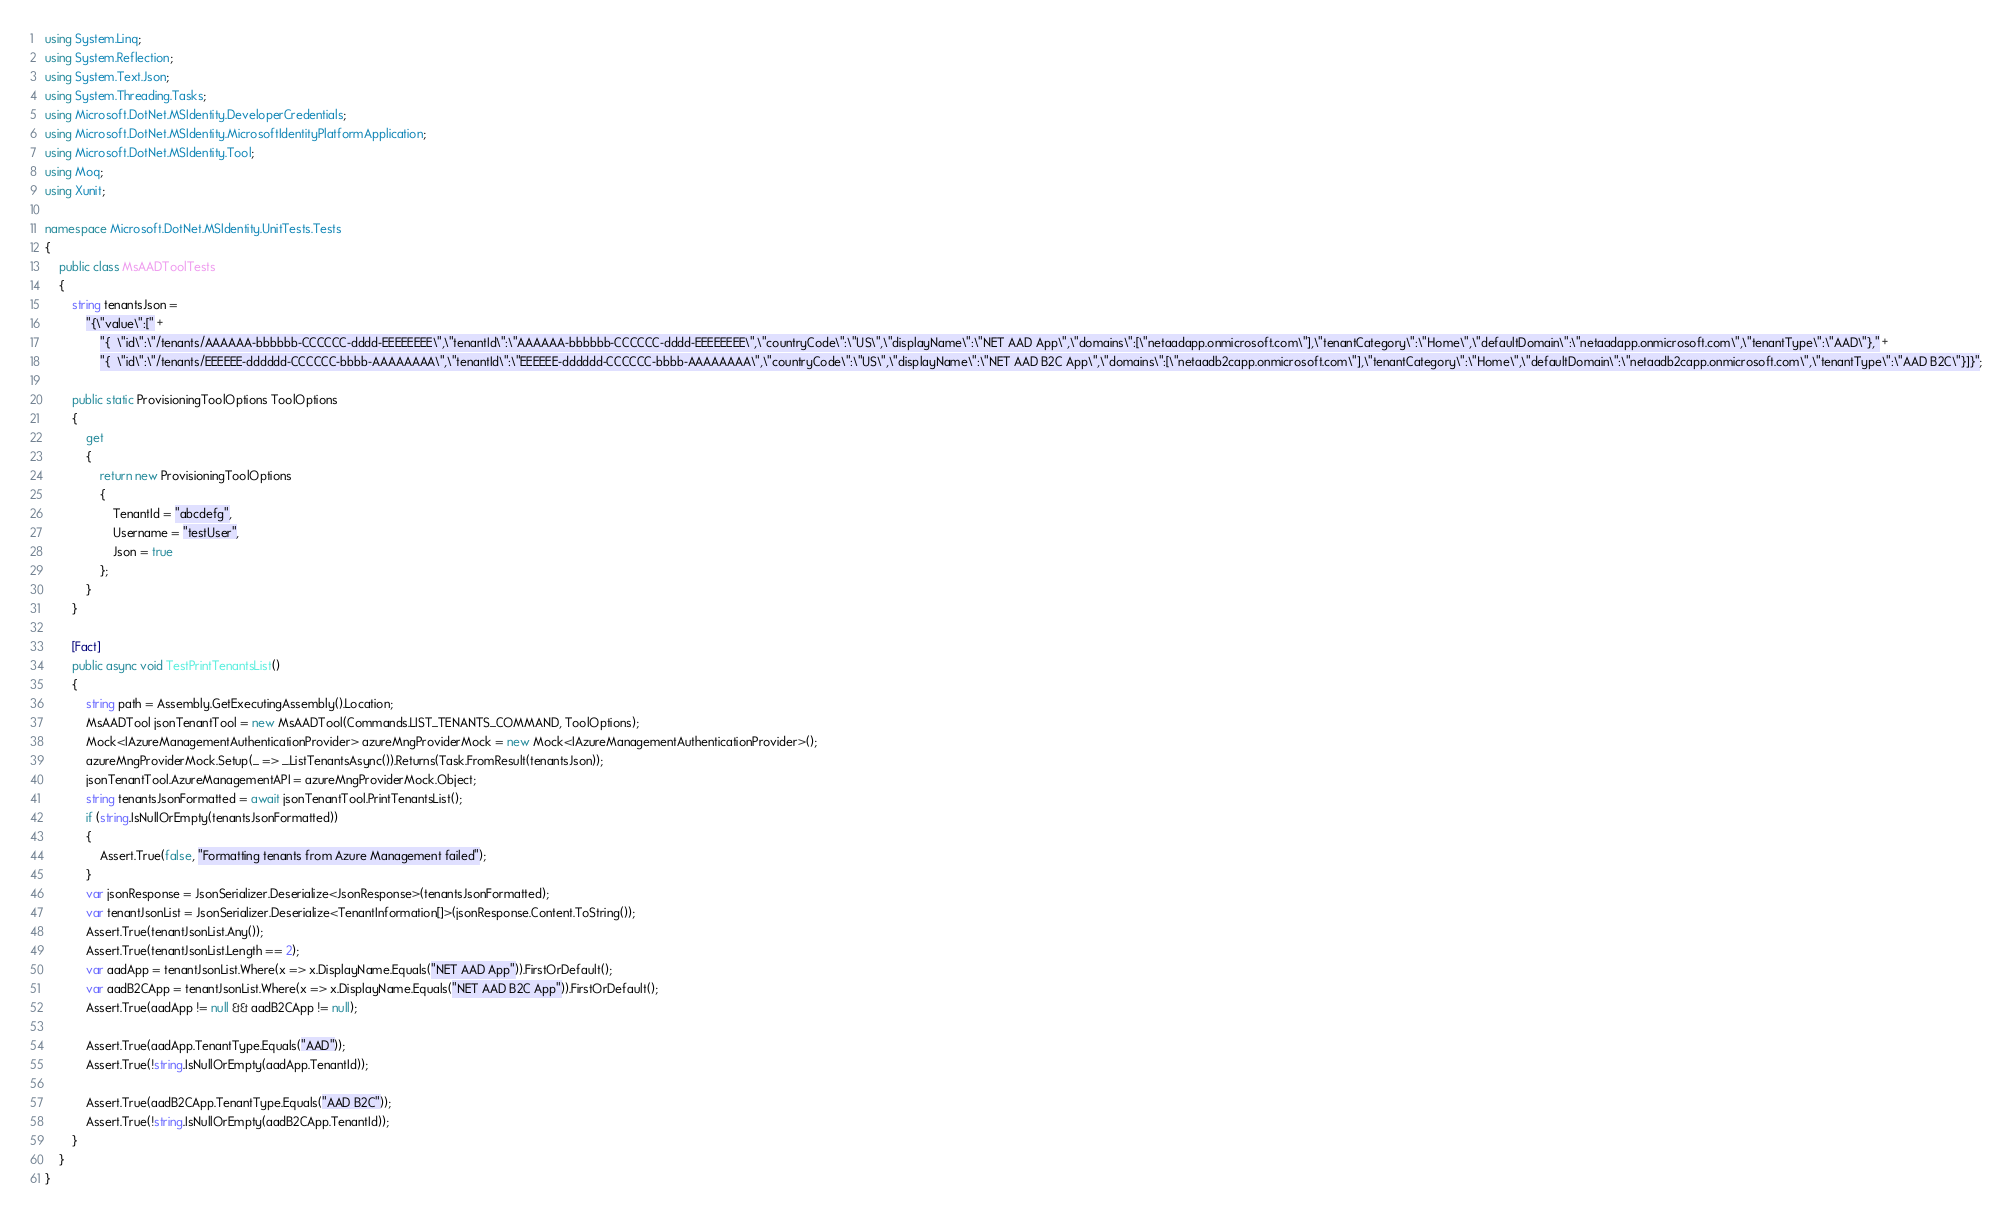Convert code to text. <code><loc_0><loc_0><loc_500><loc_500><_C#_>using System.Linq;
using System.Reflection;
using System.Text.Json;
using System.Threading.Tasks;
using Microsoft.DotNet.MSIdentity.DeveloperCredentials;
using Microsoft.DotNet.MSIdentity.MicrosoftIdentityPlatformApplication;
using Microsoft.DotNet.MSIdentity.Tool;
using Moq;
using Xunit;

namespace Microsoft.DotNet.MSIdentity.UnitTests.Tests
{
    public class MsAADToolTests
    {
        string tenantsJson =
            "{\"value\":[" +
                "{  \"id\":\"/tenants/AAAAAA-bbbbbb-CCCCCC-dddd-EEEEEEEE\",\"tenantId\":\"AAAAAA-bbbbbb-CCCCCC-dddd-EEEEEEEE\",\"countryCode\":\"US\",\"displayName\":\"NET AAD App\",\"domains\":[\"netaadapp.onmicrosoft.com\"],\"tenantCategory\":\"Home\",\"defaultDomain\":\"netaadapp.onmicrosoft.com\",\"tenantType\":\"AAD\"}," +
                "{  \"id\":\"/tenants/EEEEEE-dddddd-CCCCCC-bbbb-AAAAAAAA\",\"tenantId\":\"EEEEEE-dddddd-CCCCCC-bbbb-AAAAAAAA\",\"countryCode\":\"US\",\"displayName\":\"NET AAD B2C App\",\"domains\":[\"netaadb2capp.onmicrosoft.com\"],\"tenantCategory\":\"Home\",\"defaultDomain\":\"netaadb2capp.onmicrosoft.com\",\"tenantType\":\"AAD B2C\"}]}";

        public static ProvisioningToolOptions ToolOptions 
        {
            get 
            {
                return new ProvisioningToolOptions 
                {
                    TenantId = "abcdefg",
                    Username = "testUser",
                    Json = true
                };
            }
        }

        [Fact]
        public async void TestPrintTenantsList()
        {
            string path = Assembly.GetExecutingAssembly().Location;
            MsAADTool jsonTenantTool = new MsAADTool(Commands.LIST_TENANTS_COMMAND, ToolOptions);
            Mock<IAzureManagementAuthenticationProvider> azureMngProviderMock = new Mock<IAzureManagementAuthenticationProvider>();
            azureMngProviderMock.Setup(_ => _.ListTenantsAsync()).Returns(Task.FromResult(tenantsJson));
            jsonTenantTool.AzureManagementAPI = azureMngProviderMock.Object;
            string tenantsJsonFormatted = await jsonTenantTool.PrintTenantsList();
            if (string.IsNullOrEmpty(tenantsJsonFormatted))
            {
                Assert.True(false, "Formatting tenants from Azure Management failed");
            }
            var jsonResponse = JsonSerializer.Deserialize<JsonResponse>(tenantsJsonFormatted);
            var tenantJsonList = JsonSerializer.Deserialize<TenantInformation[]>(jsonResponse.Content.ToString());
            Assert.True(tenantJsonList.Any());
            Assert.True(tenantJsonList.Length == 2);
            var aadApp = tenantJsonList.Where(x => x.DisplayName.Equals("NET AAD App")).FirstOrDefault();
            var aadB2CApp = tenantJsonList.Where(x => x.DisplayName.Equals("NET AAD B2C App")).FirstOrDefault();
            Assert.True(aadApp != null && aadB2CApp != null);

            Assert.True(aadApp.TenantType.Equals("AAD"));
            Assert.True(!string.IsNullOrEmpty(aadApp.TenantId));

            Assert.True(aadB2CApp.TenantType.Equals("AAD B2C"));
            Assert.True(!string.IsNullOrEmpty(aadB2CApp.TenantId));
        }
    }
}
</code> 